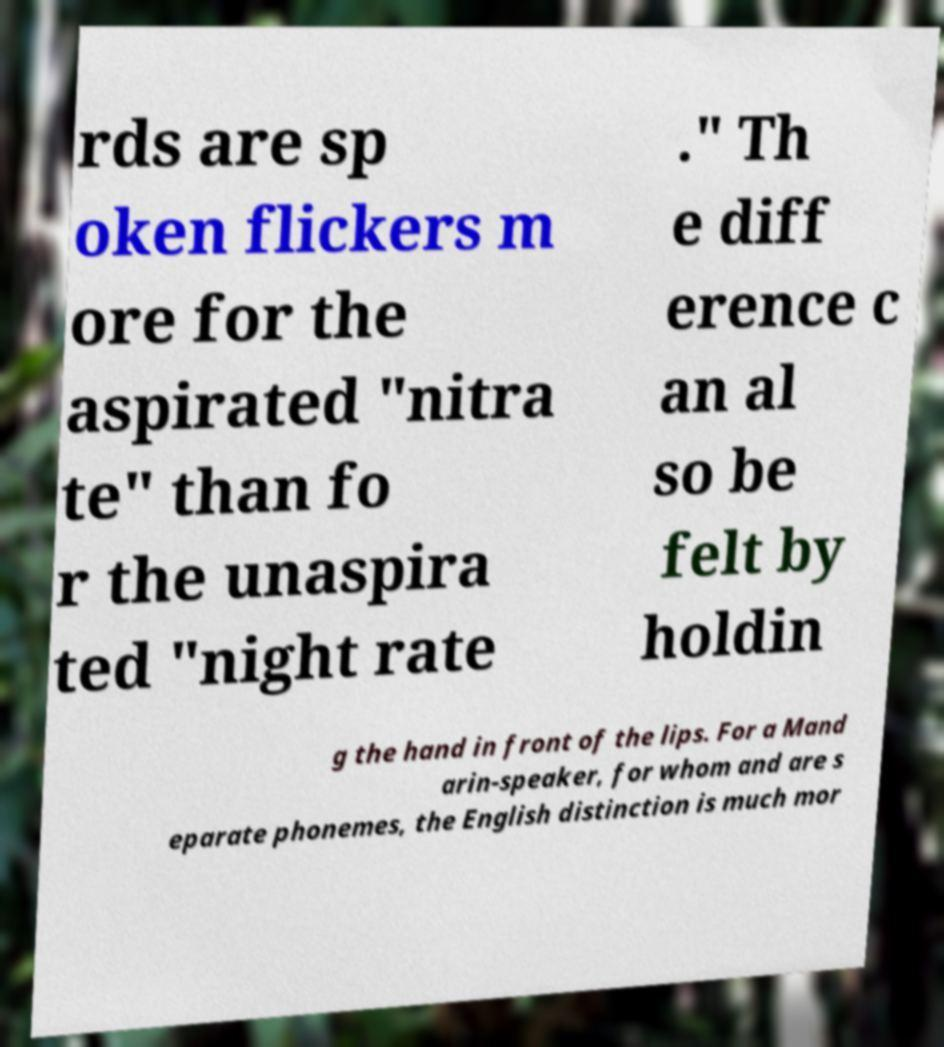Can you accurately transcribe the text from the provided image for me? rds are sp oken flickers m ore for the aspirated "nitra te" than fo r the unaspira ted "night rate ." Th e diff erence c an al so be felt by holdin g the hand in front of the lips. For a Mand arin-speaker, for whom and are s eparate phonemes, the English distinction is much mor 